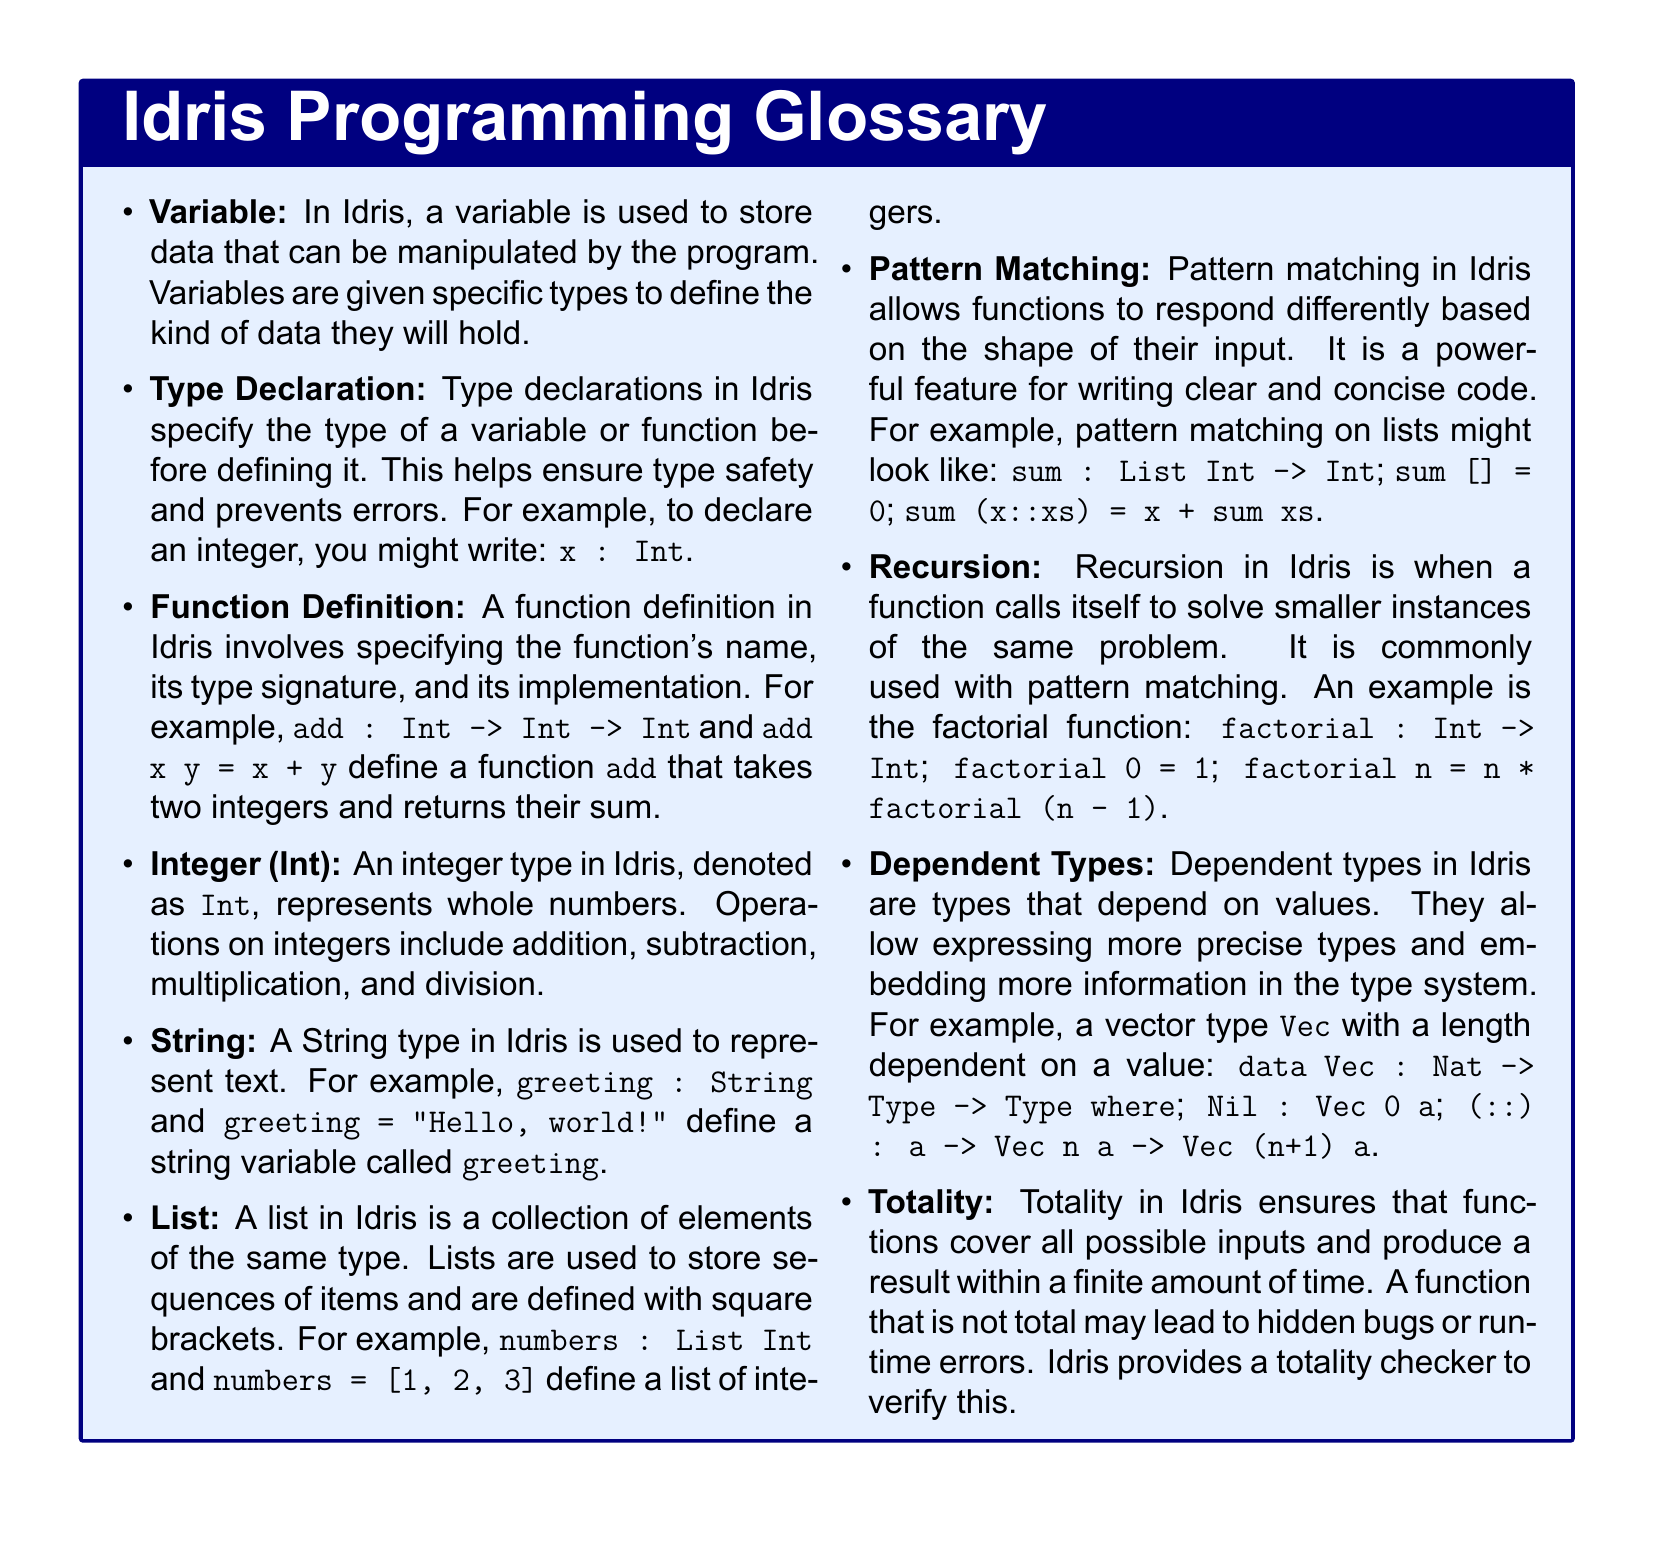What is the type of a variable in Idris? Variables in Idris are given specific types to define the kind of data they will hold.
Answer: specific types What is an example of a function definition in Idris? A function definition involves specifying the function's name, type signature, and implementation.
Answer: add : Int -> Int -> Int What does Pattern Matching allow in Idris? Pattern matching allows functions to respond differently based on the shape of their input.
Answer: respond differently What type of data does the List construct in Idris hold? A list in Idris is a collection of elements of the same type.
Answer: same type What does Totality in Idris ensure? Totality ensures that functions cover all possible inputs and produce a result within a finite amount of time.
Answer: all possible inputs What is an example of a dependent type in Idris? Dependent types allow expressing more precise types and embedding more information in the type system.
Answer: Vec How can recursion be utilized in Idris? Recursion is used when a function calls itself to solve smaller instances of the same problem.
Answer: calls itself What type of numbers can the Integer type represent in Idris? The Integer type represents whole numbers.
Answer: whole numbers What is the output of the sum function when applied to an empty list? The sum function on an empty list produces a result of 0.
Answer: 0 